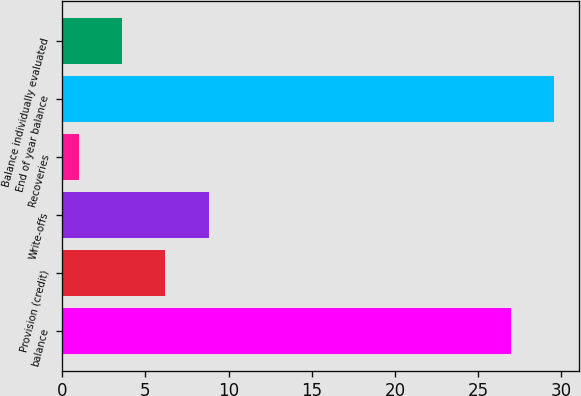<chart> <loc_0><loc_0><loc_500><loc_500><bar_chart><fcel>balance<fcel>Provision (credit)<fcel>Write-offs<fcel>Recoveries<fcel>End of year balance<fcel>Balance individually evaluated<nl><fcel>27<fcel>6.2<fcel>8.8<fcel>1<fcel>29.6<fcel>3.6<nl></chart> 